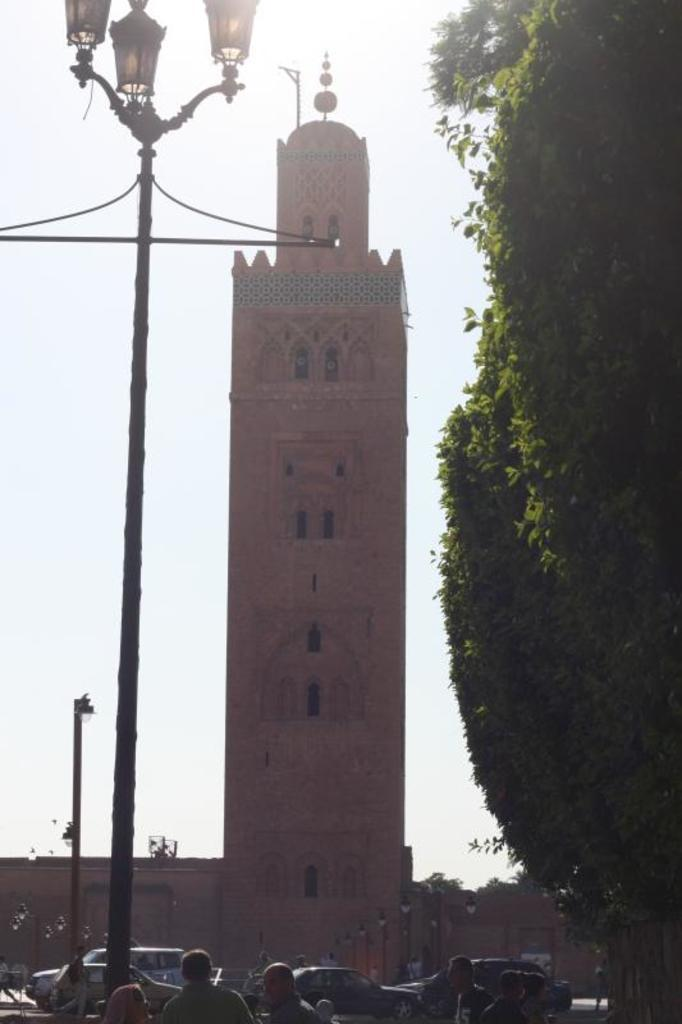What is the main structure in the center of the image? There is a building in the center of the image. What can be seen illuminating the area in the image? There are light poles in the image. What type of natural elements are present in the image? There are trees in the image. What type of transportation can be seen in the image? There are vehicles on the road in the image. Are there any living beings visible in the image? Yes, there are people in the image. What is visible at the top of the image? The sky is visible at the top of the image. What discovery was made by the face on the building in the image? There is no face present on the building in the image, and therefore no discovery can be attributed to it. 